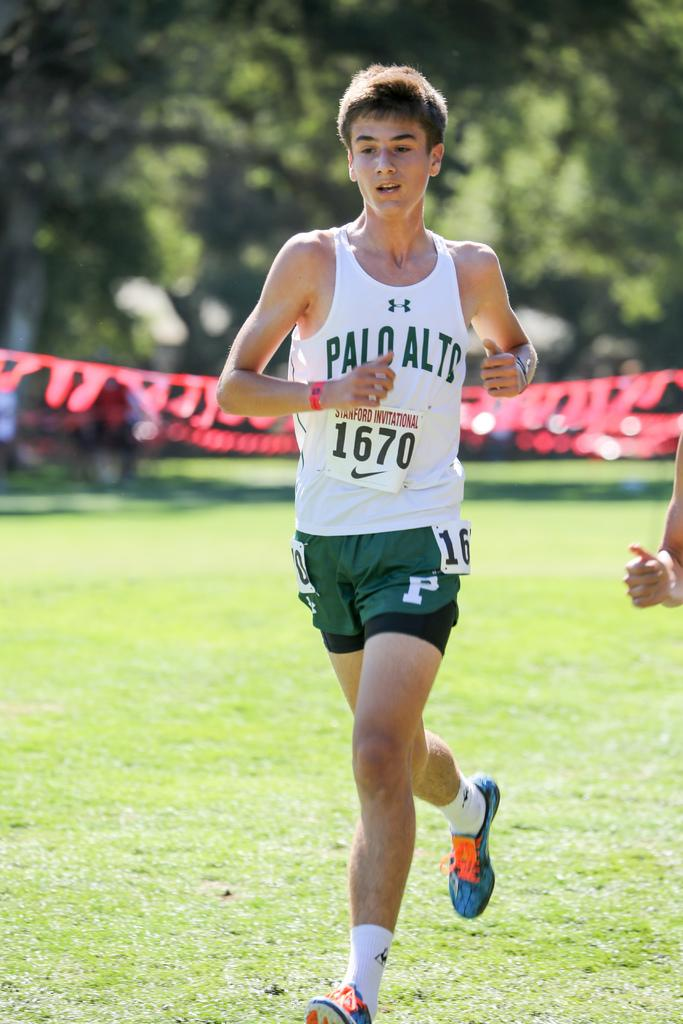<image>
Give a short and clear explanation of the subsequent image. A young man is running in a white top which has the words Palo Alto  on it and the number 1670 